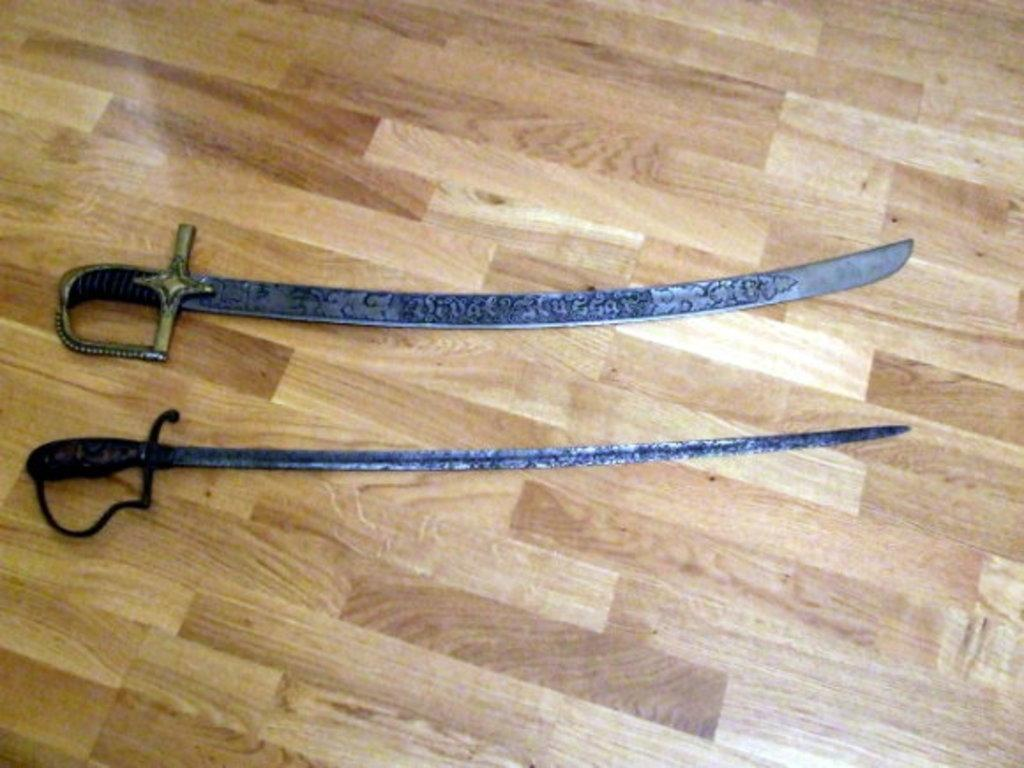What weapons are present in the image? There are two swords in the image. Where are the swords located? The swords are on the floor. What time of day is it in the image? The time of day is not mentioned or depicted in the image, so it cannot be determined. 